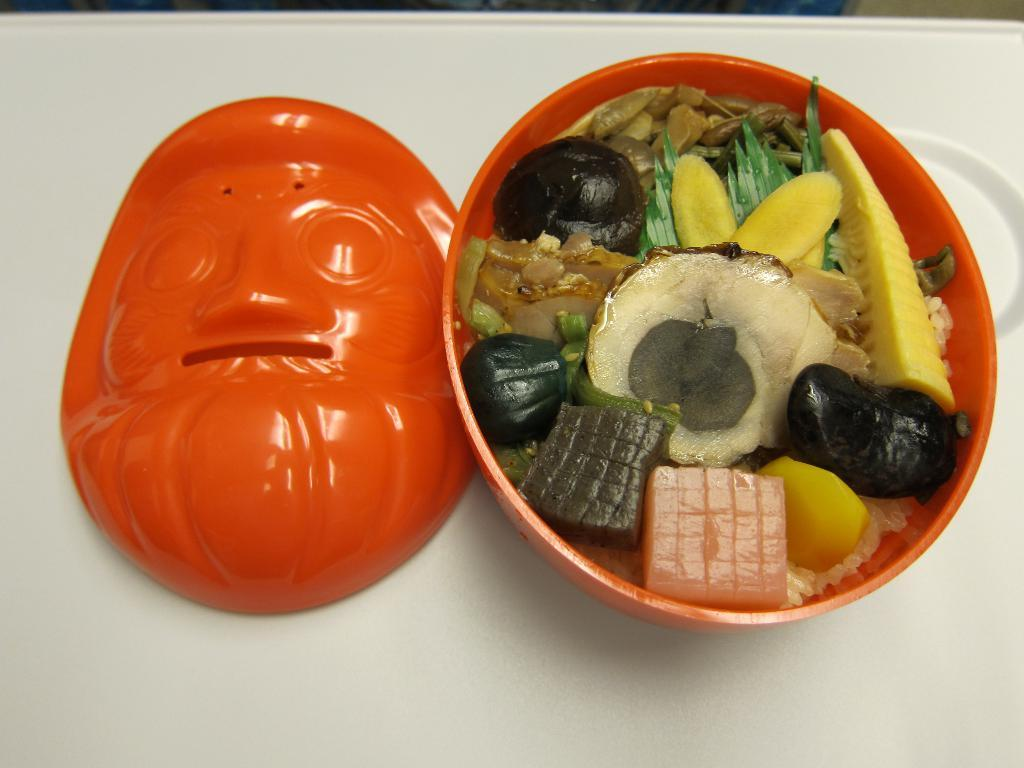What is present in the image that can hold food or other items? There is a bowl in the image. What color is the bowl? The bowl is orange in color. What is inside the bowl? There are eatables in the bowl. What is located on the left side of the image? There is a lid on the left side of the image. Where are the bowl and lid placed? The bowl and lid are on a table. What color is the table? The table is white in color. How does the carriage move around in the image? There is no carriage present in the image. What type of knot is used to secure the lid on the bowl? The image does not show any knots being used to secure the lid on the bowl. 